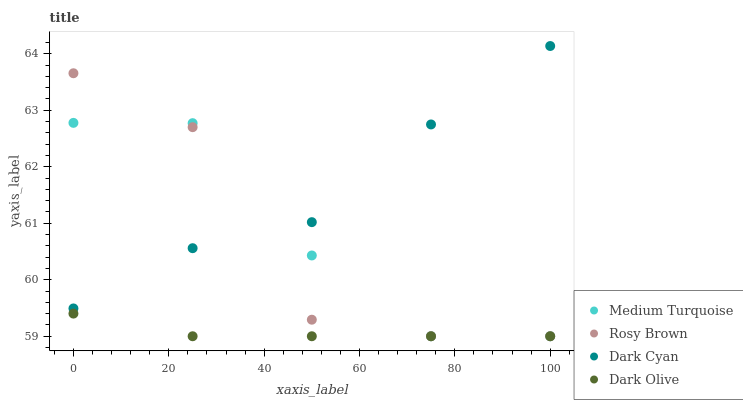Does Dark Olive have the minimum area under the curve?
Answer yes or no. Yes. Does Dark Cyan have the maximum area under the curve?
Answer yes or no. Yes. Does Rosy Brown have the minimum area under the curve?
Answer yes or no. No. Does Rosy Brown have the maximum area under the curve?
Answer yes or no. No. Is Dark Olive the smoothest?
Answer yes or no. Yes. Is Rosy Brown the roughest?
Answer yes or no. Yes. Is Rosy Brown the smoothest?
Answer yes or no. No. Is Dark Olive the roughest?
Answer yes or no. No. Does Rosy Brown have the lowest value?
Answer yes or no. Yes. Does Dark Cyan have the highest value?
Answer yes or no. Yes. Does Rosy Brown have the highest value?
Answer yes or no. No. Is Dark Olive less than Dark Cyan?
Answer yes or no. Yes. Is Dark Cyan greater than Dark Olive?
Answer yes or no. Yes. Does Dark Cyan intersect Rosy Brown?
Answer yes or no. Yes. Is Dark Cyan less than Rosy Brown?
Answer yes or no. No. Is Dark Cyan greater than Rosy Brown?
Answer yes or no. No. Does Dark Olive intersect Dark Cyan?
Answer yes or no. No. 